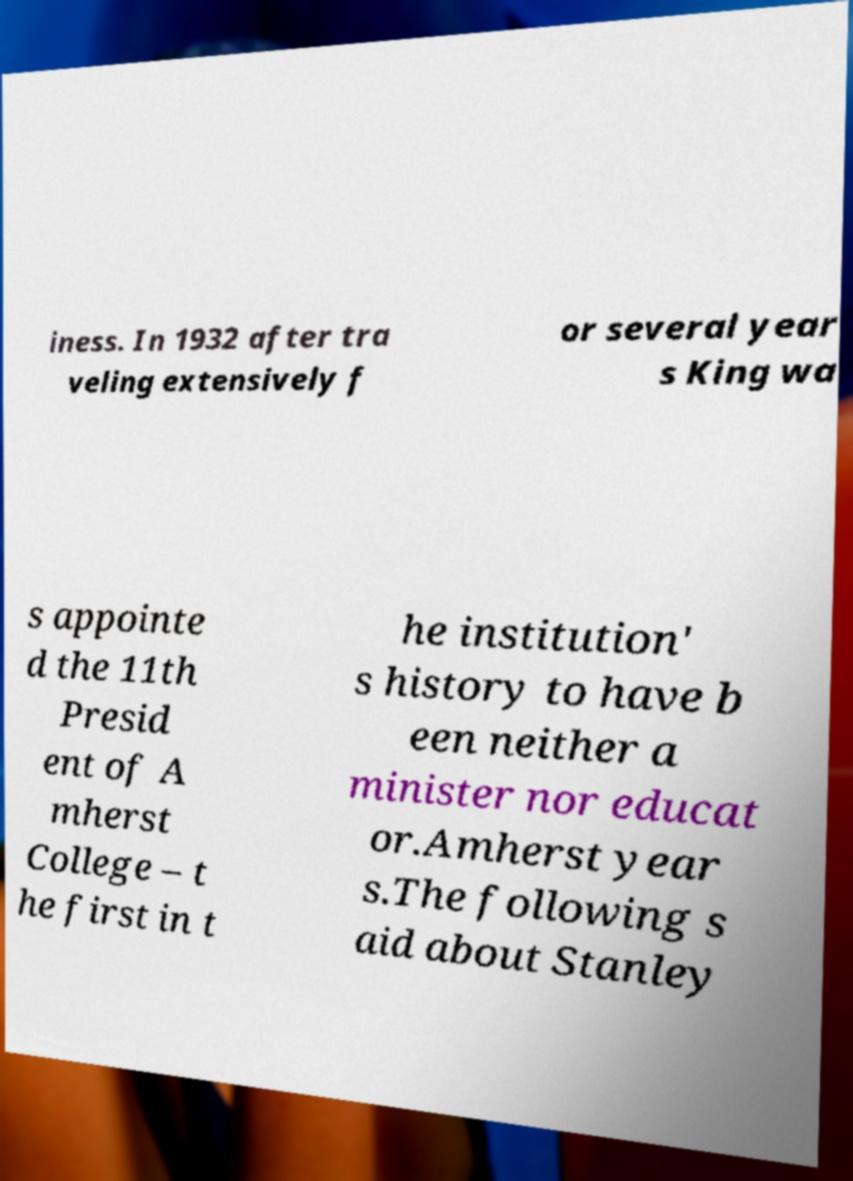What messages or text are displayed in this image? I need them in a readable, typed format. iness. In 1932 after tra veling extensively f or several year s King wa s appointe d the 11th Presid ent of A mherst College – t he first in t he institution' s history to have b een neither a minister nor educat or.Amherst year s.The following s aid about Stanley 